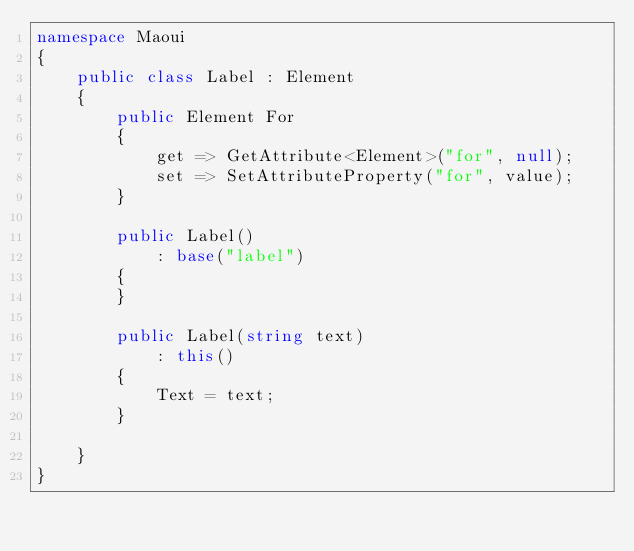<code> <loc_0><loc_0><loc_500><loc_500><_C#_>namespace Maoui
{
    public class Label : Element
    {
        public Element For
        {
            get => GetAttribute<Element>("for", null);
            set => SetAttributeProperty("for", value);
        }

        public Label()
            : base("label")
        {
        }

        public Label(string text)
            : this()
        {
            Text = text;
        }

    }
}
</code> 